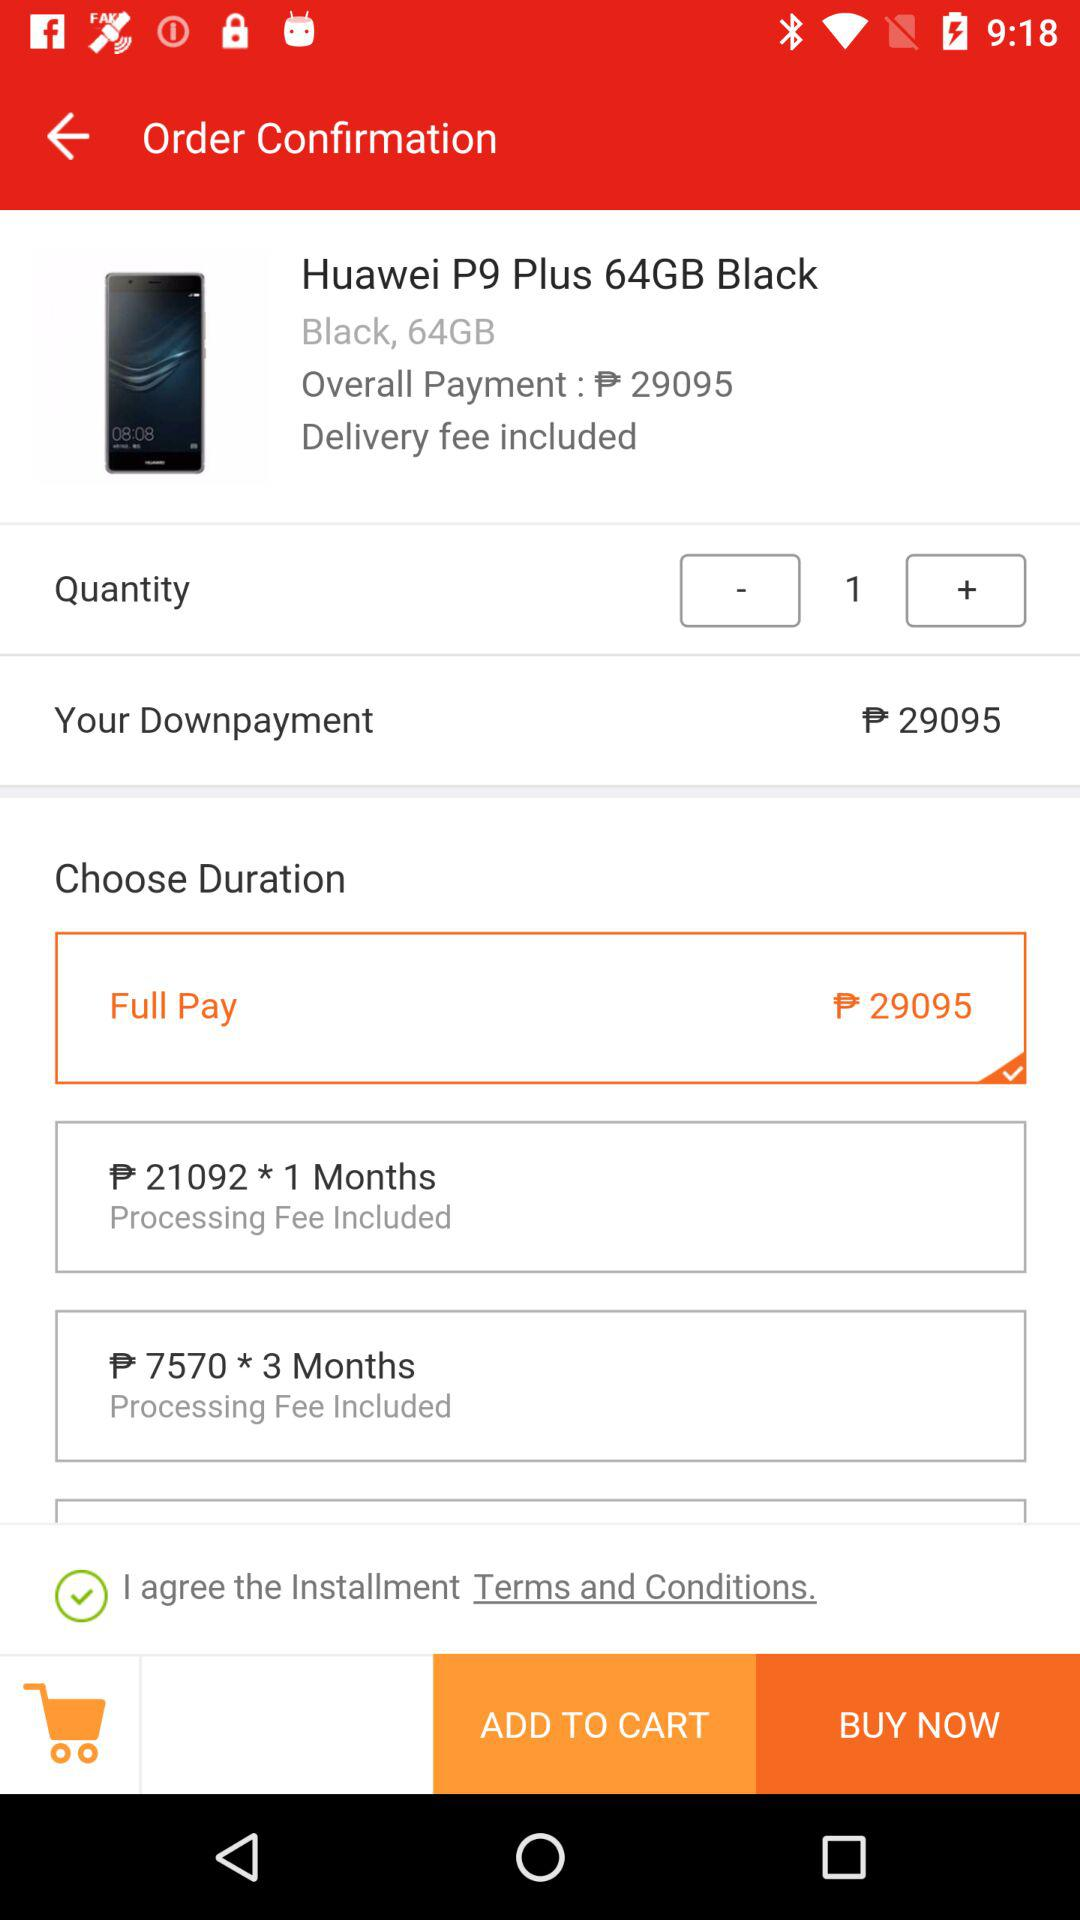How much is the storage of the product? The storage of the product is 64GB. 